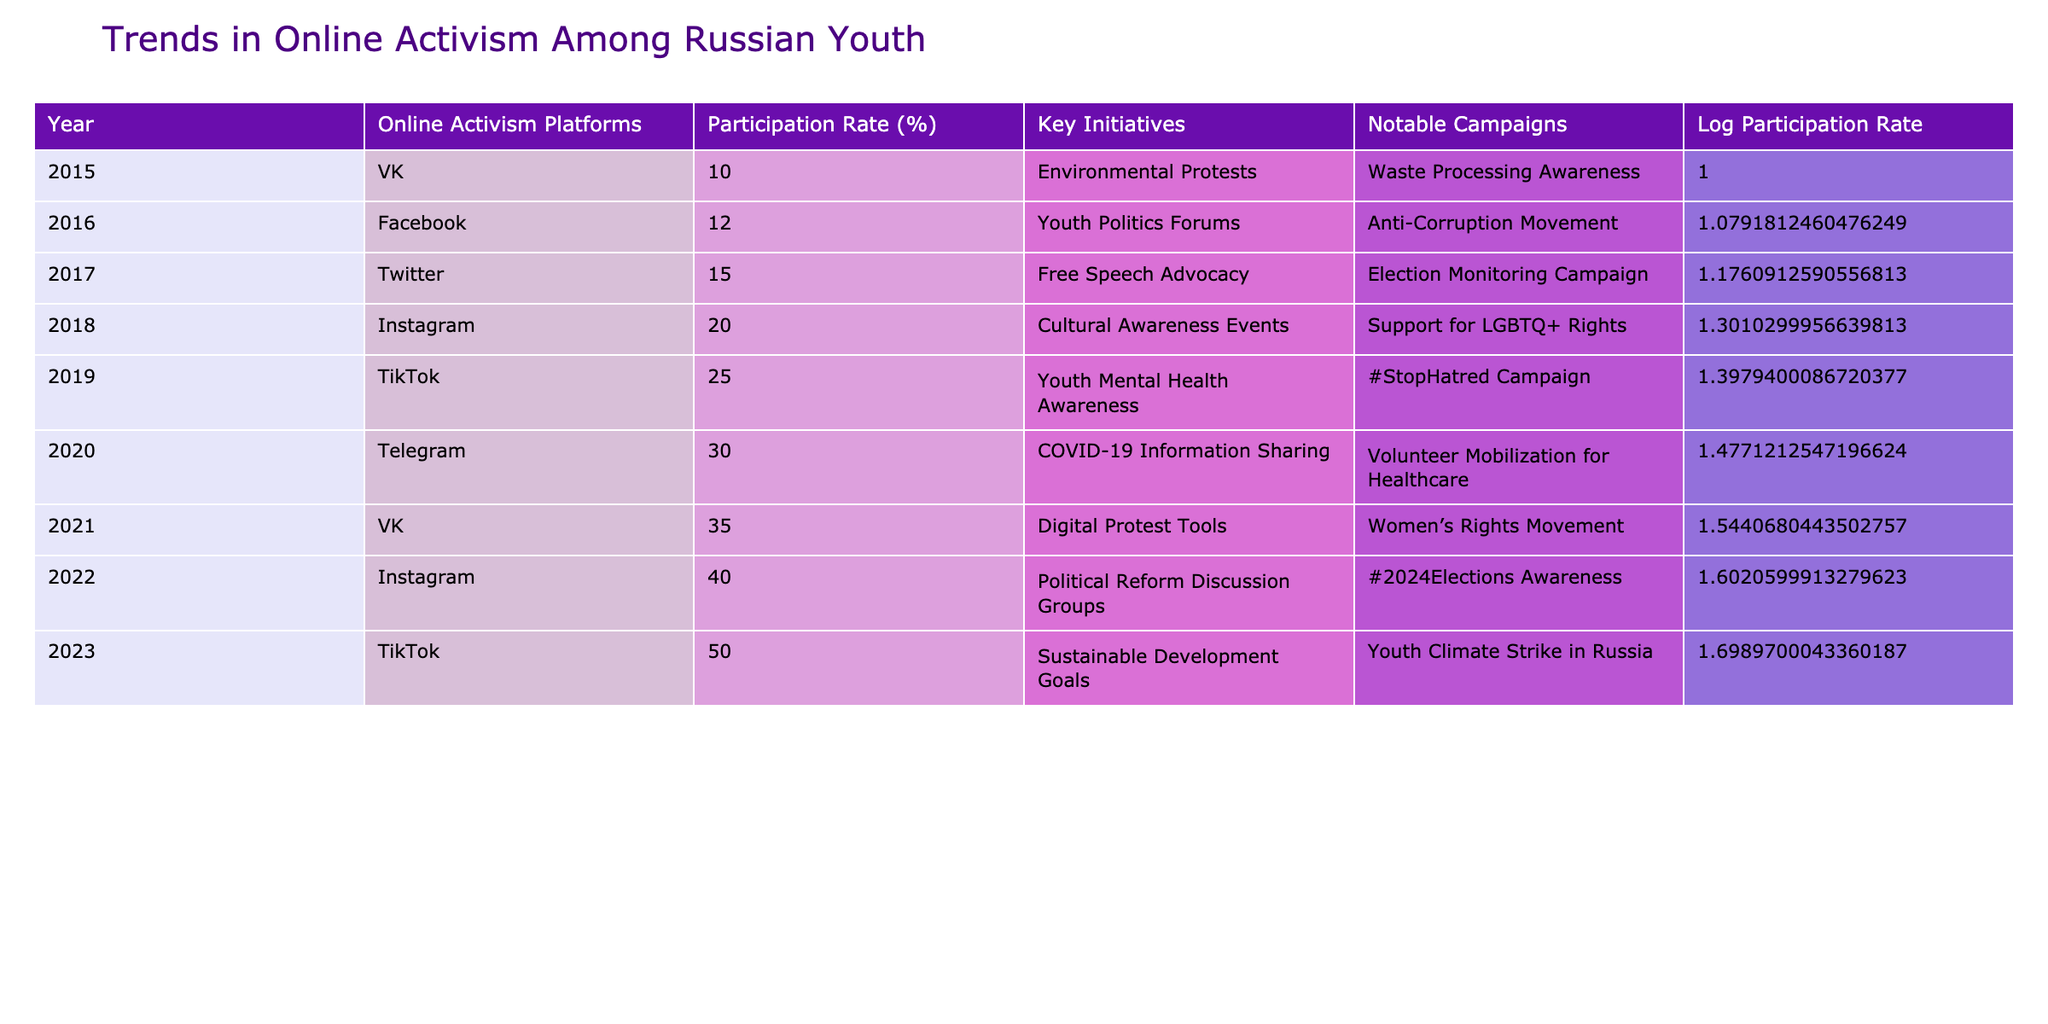What was the highest participation rate in online activism among Russian youth? The table shows the participation rates for each year, with the highest value being 50% in 2023 for TikTok.
Answer: 50% Which online platform saw a growth in participation rate from 2015 to 2021? Observing the table, VK's participation rate increased from 10% in 2015 to 35% in 2021, indicating a consistent growth.
Answer: VK Is it true that Instagram was used for more initiatives than TikTok in 2023? In the table, TikTok has 1 initiative listed for 2023, while Instagram has 1 initiative as well. Therefore, it's not true that Instagram had more initiatives than TikTok.
Answer: No What was the average participation rate from 2015 to 2021? To calculate the average, we sum the participation rates from 2015 (10), 2016 (12), 2017 (15), 2018 (20), 2019 (25), 2020 (30), and 2021 (35) which equals 122, then divide by the number of years (7): 122/7 = approximately 17.43.
Answer: Approximately 17.43 Which year had the highest percentage increase in participation rate over the previous year? Comparing the participation rates year over year, from 2022 (40%) to 2023 (50%) shows the greatest increase of 10%, indicating significant growth.
Answer: 2022 to 2023 How many platforms had a participation rate above 30% by 2022? By examining the table, the platforms with rates above 30% are Telegram (30% in 2020), VK (35% in 2021), and Instagram (40% in 2022). Therefore, there are 3 platforms with rates above 30% by 2022.
Answer: 3 Did Facebook have a higher participation rate than Twitter in 2017? The table shows Facebook's participation rate was 12% in 2016, while Twitter's was 15% in 2017, indicating Facebook did not have a higher rate than Twitter in 2017.
Answer: No What was the total number of initiatives mentioned from 2015 to 2023? The table lists 9 different initiatives across the years, so the total number of initiatives mentioned is 9.
Answer: 9 